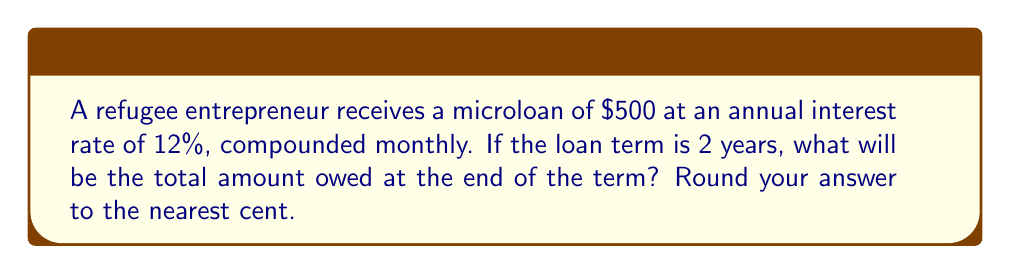Give your solution to this math problem. To solve this problem, we'll use the compound interest formula:

$$ A = P(1 + \frac{r}{n})^{nt} $$

Where:
$A$ = Final amount
$P$ = Principal (initial loan amount)
$r$ = Annual interest rate (in decimal form)
$n$ = Number of times interest is compounded per year
$t$ = Number of years

Given:
$P = 500$
$r = 0.12$ (12% written as a decimal)
$n = 12$ (compounded monthly)
$t = 2$ years

Let's substitute these values into the formula:

$$ A = 500(1 + \frac{0.12}{12})^{12 \cdot 2} $$

$$ A = 500(1 + 0.01)^{24} $$

$$ A = 500(1.01)^{24} $$

Using a calculator or computer:

$$ A = 500 \cdot 1.2697053 $$

$$ A = 634.85265 $$

Rounding to the nearest cent:

$$ A = 634.85 $$
Answer: $634.85 